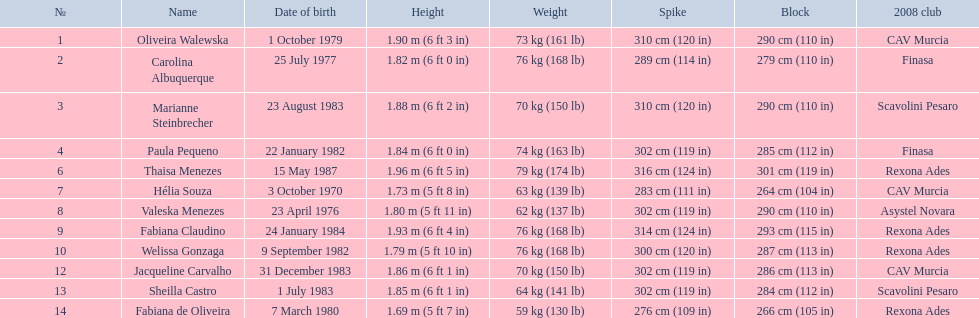What is the weight of fabiana de oliveira? 76 kg (168 lb). What is the weight of helia souza? 63 kg (139 lb). What is the weight of sheilla castro? 64 kg (141 lb). Whom did the original question poser wrongly assume to be the heaviest (while they are the second heaviest)? Sheilla Castro. 